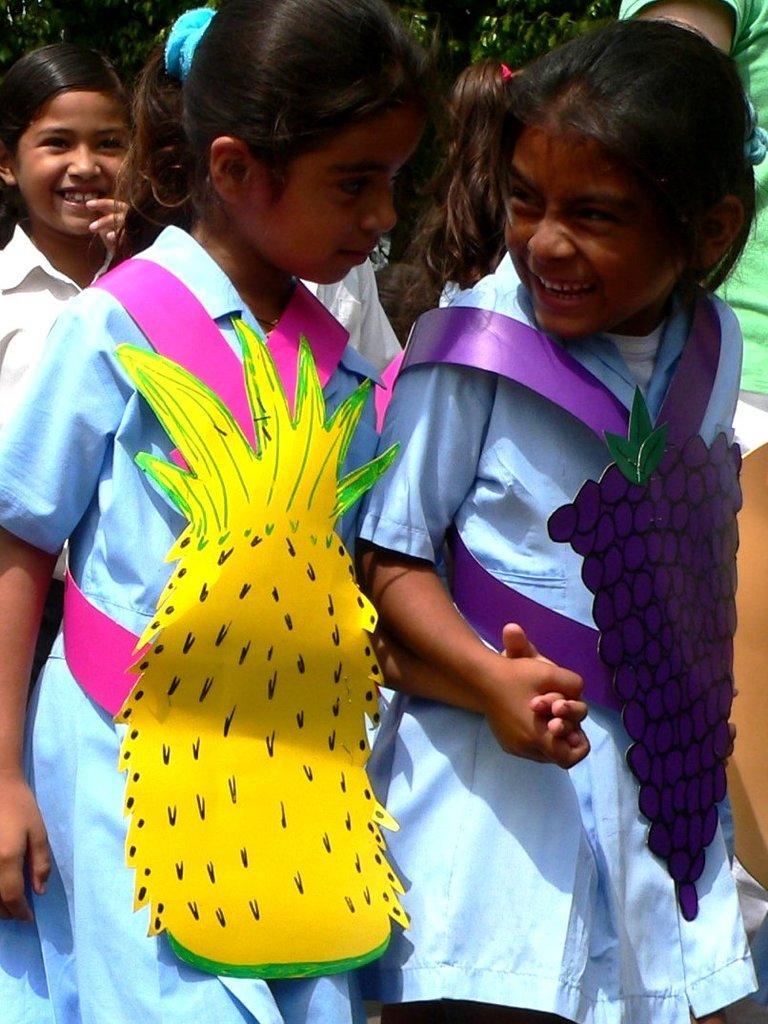In one or two sentences, can you explain what this image depicts? In this image there is a group of girls, there are wearing uniforms, there are fruits made of chart, there are trees towards the background of the image. 